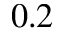<formula> <loc_0><loc_0><loc_500><loc_500>0 . 2</formula> 